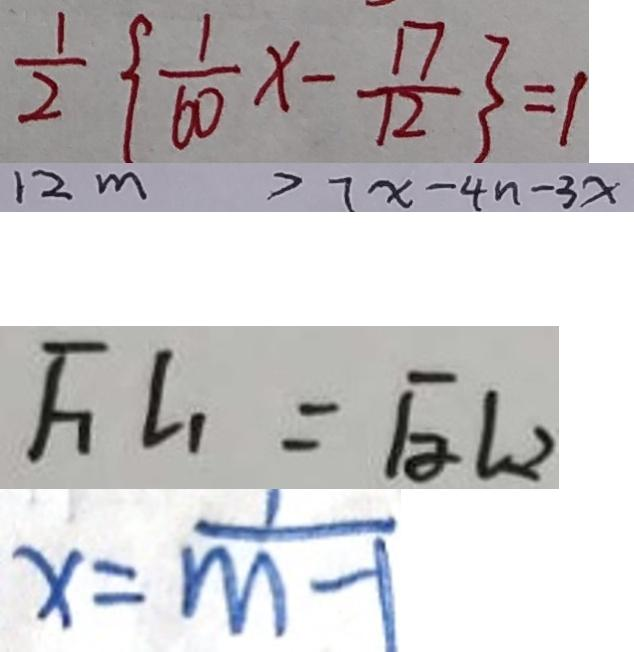<formula> <loc_0><loc_0><loc_500><loc_500>\frac { 1 } { 2 } \{ \frac { 1 } { 6 0 } x - \frac { 1 7 } { 1 2 } \} = 1 
 1 2 m > 7 x - 4 n - 3 x 
 F _ { 1 } L _ { 1 } = F _ { 2 } L _ { 2 } 
 x = \frac { 1 } { m - 1 }</formula> 